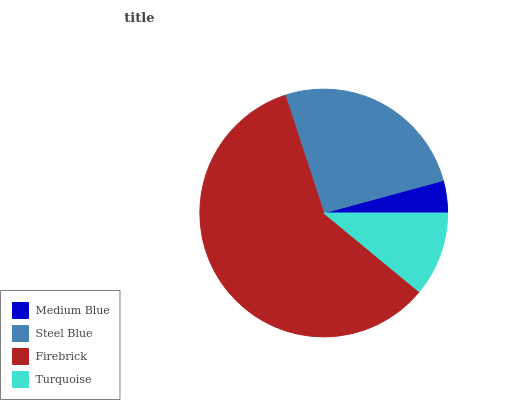Is Medium Blue the minimum?
Answer yes or no. Yes. Is Firebrick the maximum?
Answer yes or no. Yes. Is Steel Blue the minimum?
Answer yes or no. No. Is Steel Blue the maximum?
Answer yes or no. No. Is Steel Blue greater than Medium Blue?
Answer yes or no. Yes. Is Medium Blue less than Steel Blue?
Answer yes or no. Yes. Is Medium Blue greater than Steel Blue?
Answer yes or no. No. Is Steel Blue less than Medium Blue?
Answer yes or no. No. Is Steel Blue the high median?
Answer yes or no. Yes. Is Turquoise the low median?
Answer yes or no. Yes. Is Medium Blue the high median?
Answer yes or no. No. Is Steel Blue the low median?
Answer yes or no. No. 